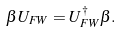<formula> <loc_0><loc_0><loc_500><loc_500>\beta U _ { F W } = U ^ { \dag } _ { F W } \beta .</formula> 